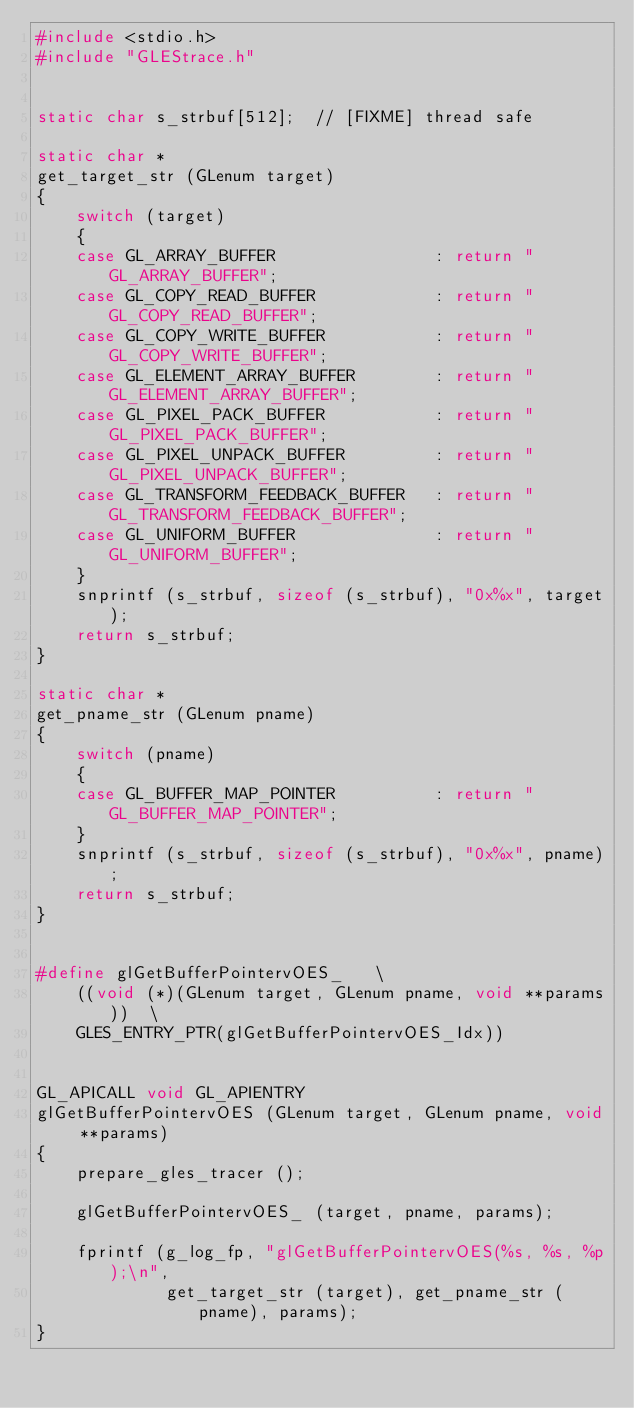Convert code to text. <code><loc_0><loc_0><loc_500><loc_500><_C_>#include <stdio.h>
#include "GLEStrace.h"


static char s_strbuf[512];  // [FIXME] thread safe

static char *
get_target_str (GLenum target)
{
    switch (target)
    {
    case GL_ARRAY_BUFFER                : return "GL_ARRAY_BUFFER";
    case GL_COPY_READ_BUFFER            : return "GL_COPY_READ_BUFFER";
    case GL_COPY_WRITE_BUFFER           : return "GL_COPY_WRITE_BUFFER";
    case GL_ELEMENT_ARRAY_BUFFER        : return "GL_ELEMENT_ARRAY_BUFFER";
    case GL_PIXEL_PACK_BUFFER           : return "GL_PIXEL_PACK_BUFFER";
    case GL_PIXEL_UNPACK_BUFFER         : return "GL_PIXEL_UNPACK_BUFFER";
    case GL_TRANSFORM_FEEDBACK_BUFFER   : return "GL_TRANSFORM_FEEDBACK_BUFFER";
    case GL_UNIFORM_BUFFER              : return "GL_UNIFORM_BUFFER";
    }
    snprintf (s_strbuf, sizeof (s_strbuf), "0x%x", target);
    return s_strbuf;
}

static char *
get_pname_str (GLenum pname)
{
    switch (pname)
    {
    case GL_BUFFER_MAP_POINTER          : return "GL_BUFFER_MAP_POINTER";
    }
    snprintf (s_strbuf, sizeof (s_strbuf), "0x%x", pname);
    return s_strbuf;
}


#define glGetBufferPointervOES_   \
    ((void (*)(GLenum target, GLenum pname, void **params))  \
    GLES_ENTRY_PTR(glGetBufferPointervOES_Idx))


GL_APICALL void GL_APIENTRY
glGetBufferPointervOES (GLenum target, GLenum pname, void **params)
{
    prepare_gles_tracer ();

    glGetBufferPointervOES_ (target, pname, params);

    fprintf (g_log_fp, "glGetBufferPointervOES(%s, %s, %p);\n",
             get_target_str (target), get_pname_str (pname), params);
}

</code> 